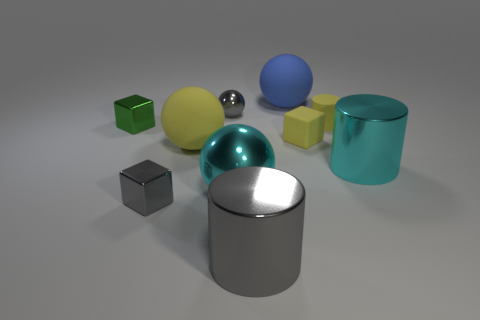How many other objects are there of the same size as the yellow block?
Offer a very short reply. 4. What number of things are cyan metal objects or big gray metallic cylinders in front of the cyan cylinder?
Offer a terse response. 3. Is the number of shiny things that are in front of the tiny gray metal block the same as the number of small shiny spheres?
Provide a short and direct response. Yes. What shape is the large gray object that is the same material as the tiny sphere?
Your answer should be compact. Cylinder. Is there a big metal cylinder of the same color as the rubber cylinder?
Make the answer very short. No. How many metal things are gray objects or large red things?
Your response must be concise. 3. How many cyan spheres are behind the small yellow matte object to the right of the small yellow cube?
Make the answer very short. 0. What number of large objects have the same material as the small green block?
Make the answer very short. 3. What number of tiny objects are either yellow objects or yellow rubber blocks?
Keep it short and to the point. 2. There is a matte thing that is both in front of the tiny yellow rubber cylinder and on the right side of the large blue thing; what shape is it?
Your response must be concise. Cube. 